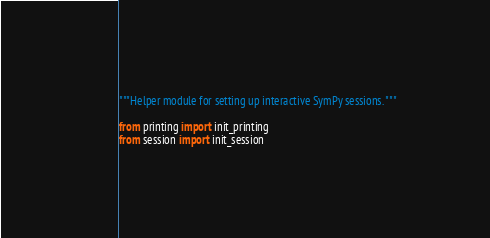Convert code to text. <code><loc_0><loc_0><loc_500><loc_500><_Python_>"""Helper module for setting up interactive SymPy sessions. """

from printing import init_printing
from session import init_session
</code> 